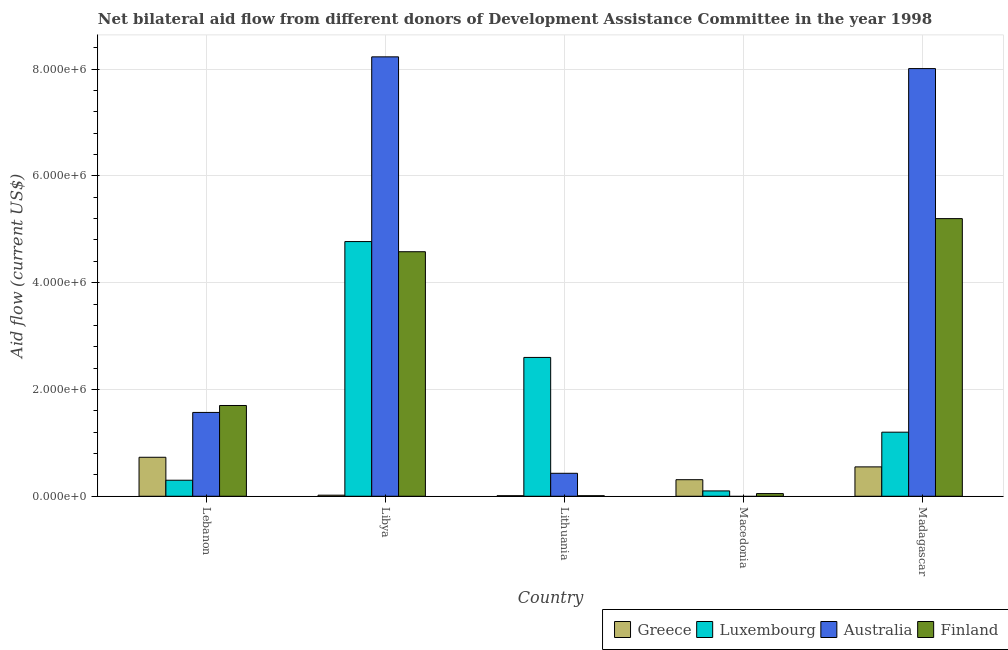How many different coloured bars are there?
Offer a very short reply. 4. How many groups of bars are there?
Your answer should be very brief. 5. How many bars are there on the 3rd tick from the left?
Your answer should be very brief. 4. What is the label of the 1st group of bars from the left?
Ensure brevity in your answer.  Lebanon. What is the amount of aid given by finland in Lithuania?
Ensure brevity in your answer.  10000. Across all countries, what is the maximum amount of aid given by luxembourg?
Your response must be concise. 4.77e+06. Across all countries, what is the minimum amount of aid given by luxembourg?
Offer a very short reply. 1.00e+05. In which country was the amount of aid given by luxembourg maximum?
Give a very brief answer. Libya. What is the total amount of aid given by luxembourg in the graph?
Make the answer very short. 8.97e+06. What is the difference between the amount of aid given by finland in Libya and that in Macedonia?
Make the answer very short. 4.53e+06. What is the difference between the amount of aid given by finland in Madagascar and the amount of aid given by luxembourg in Libya?
Ensure brevity in your answer.  4.30e+05. What is the average amount of aid given by luxembourg per country?
Keep it short and to the point. 1.79e+06. What is the difference between the amount of aid given by luxembourg and amount of aid given by greece in Macedonia?
Provide a short and direct response. -2.10e+05. What is the ratio of the amount of aid given by luxembourg in Libya to that in Madagascar?
Ensure brevity in your answer.  3.98. What is the difference between the highest and the second highest amount of aid given by australia?
Provide a succinct answer. 2.20e+05. What is the difference between the highest and the lowest amount of aid given by finland?
Keep it short and to the point. 5.19e+06. Is the sum of the amount of aid given by luxembourg in Lithuania and Macedonia greater than the maximum amount of aid given by australia across all countries?
Make the answer very short. No. Is it the case that in every country, the sum of the amount of aid given by greece and amount of aid given by luxembourg is greater than the amount of aid given by australia?
Your answer should be very brief. No. What is the difference between two consecutive major ticks on the Y-axis?
Your answer should be compact. 2.00e+06. Where does the legend appear in the graph?
Your response must be concise. Bottom right. How are the legend labels stacked?
Make the answer very short. Horizontal. What is the title of the graph?
Ensure brevity in your answer.  Net bilateral aid flow from different donors of Development Assistance Committee in the year 1998. What is the label or title of the X-axis?
Make the answer very short. Country. What is the Aid flow (current US$) in Greece in Lebanon?
Provide a short and direct response. 7.30e+05. What is the Aid flow (current US$) in Australia in Lebanon?
Provide a short and direct response. 1.57e+06. What is the Aid flow (current US$) of Finland in Lebanon?
Offer a terse response. 1.70e+06. What is the Aid flow (current US$) in Greece in Libya?
Provide a succinct answer. 2.00e+04. What is the Aid flow (current US$) of Luxembourg in Libya?
Offer a terse response. 4.77e+06. What is the Aid flow (current US$) in Australia in Libya?
Keep it short and to the point. 8.23e+06. What is the Aid flow (current US$) in Finland in Libya?
Ensure brevity in your answer.  4.58e+06. What is the Aid flow (current US$) of Greece in Lithuania?
Offer a terse response. 10000. What is the Aid flow (current US$) of Luxembourg in Lithuania?
Give a very brief answer. 2.60e+06. What is the Aid flow (current US$) of Finland in Lithuania?
Give a very brief answer. 10000. What is the Aid flow (current US$) of Greece in Macedonia?
Your response must be concise. 3.10e+05. What is the Aid flow (current US$) of Australia in Macedonia?
Your answer should be compact. 0. What is the Aid flow (current US$) in Finland in Macedonia?
Ensure brevity in your answer.  5.00e+04. What is the Aid flow (current US$) in Greece in Madagascar?
Ensure brevity in your answer.  5.50e+05. What is the Aid flow (current US$) of Luxembourg in Madagascar?
Your response must be concise. 1.20e+06. What is the Aid flow (current US$) in Australia in Madagascar?
Make the answer very short. 8.01e+06. What is the Aid flow (current US$) in Finland in Madagascar?
Make the answer very short. 5.20e+06. Across all countries, what is the maximum Aid flow (current US$) of Greece?
Your answer should be compact. 7.30e+05. Across all countries, what is the maximum Aid flow (current US$) of Luxembourg?
Offer a terse response. 4.77e+06. Across all countries, what is the maximum Aid flow (current US$) of Australia?
Your answer should be compact. 8.23e+06. Across all countries, what is the maximum Aid flow (current US$) of Finland?
Offer a very short reply. 5.20e+06. Across all countries, what is the minimum Aid flow (current US$) in Greece?
Provide a short and direct response. 10000. Across all countries, what is the minimum Aid flow (current US$) in Luxembourg?
Your answer should be very brief. 1.00e+05. Across all countries, what is the minimum Aid flow (current US$) of Australia?
Your answer should be compact. 0. Across all countries, what is the minimum Aid flow (current US$) in Finland?
Offer a very short reply. 10000. What is the total Aid flow (current US$) in Greece in the graph?
Give a very brief answer. 1.62e+06. What is the total Aid flow (current US$) in Luxembourg in the graph?
Offer a terse response. 8.97e+06. What is the total Aid flow (current US$) in Australia in the graph?
Your answer should be very brief. 1.82e+07. What is the total Aid flow (current US$) in Finland in the graph?
Offer a very short reply. 1.15e+07. What is the difference between the Aid flow (current US$) of Greece in Lebanon and that in Libya?
Your answer should be compact. 7.10e+05. What is the difference between the Aid flow (current US$) of Luxembourg in Lebanon and that in Libya?
Offer a terse response. -4.47e+06. What is the difference between the Aid flow (current US$) of Australia in Lebanon and that in Libya?
Your answer should be compact. -6.66e+06. What is the difference between the Aid flow (current US$) of Finland in Lebanon and that in Libya?
Your answer should be compact. -2.88e+06. What is the difference between the Aid flow (current US$) in Greece in Lebanon and that in Lithuania?
Offer a terse response. 7.20e+05. What is the difference between the Aid flow (current US$) of Luxembourg in Lebanon and that in Lithuania?
Make the answer very short. -2.30e+06. What is the difference between the Aid flow (current US$) of Australia in Lebanon and that in Lithuania?
Make the answer very short. 1.14e+06. What is the difference between the Aid flow (current US$) in Finland in Lebanon and that in Lithuania?
Your response must be concise. 1.69e+06. What is the difference between the Aid flow (current US$) in Greece in Lebanon and that in Macedonia?
Make the answer very short. 4.20e+05. What is the difference between the Aid flow (current US$) of Luxembourg in Lebanon and that in Macedonia?
Make the answer very short. 2.00e+05. What is the difference between the Aid flow (current US$) of Finland in Lebanon and that in Macedonia?
Ensure brevity in your answer.  1.65e+06. What is the difference between the Aid flow (current US$) of Luxembourg in Lebanon and that in Madagascar?
Your response must be concise. -9.00e+05. What is the difference between the Aid flow (current US$) of Australia in Lebanon and that in Madagascar?
Your response must be concise. -6.44e+06. What is the difference between the Aid flow (current US$) in Finland in Lebanon and that in Madagascar?
Offer a terse response. -3.50e+06. What is the difference between the Aid flow (current US$) in Greece in Libya and that in Lithuania?
Your answer should be compact. 10000. What is the difference between the Aid flow (current US$) of Luxembourg in Libya and that in Lithuania?
Your answer should be very brief. 2.17e+06. What is the difference between the Aid flow (current US$) in Australia in Libya and that in Lithuania?
Your answer should be compact. 7.80e+06. What is the difference between the Aid flow (current US$) of Finland in Libya and that in Lithuania?
Your response must be concise. 4.57e+06. What is the difference between the Aid flow (current US$) in Greece in Libya and that in Macedonia?
Your answer should be very brief. -2.90e+05. What is the difference between the Aid flow (current US$) in Luxembourg in Libya and that in Macedonia?
Provide a succinct answer. 4.67e+06. What is the difference between the Aid flow (current US$) of Finland in Libya and that in Macedonia?
Your answer should be very brief. 4.53e+06. What is the difference between the Aid flow (current US$) in Greece in Libya and that in Madagascar?
Ensure brevity in your answer.  -5.30e+05. What is the difference between the Aid flow (current US$) of Luxembourg in Libya and that in Madagascar?
Your response must be concise. 3.57e+06. What is the difference between the Aid flow (current US$) in Australia in Libya and that in Madagascar?
Your answer should be compact. 2.20e+05. What is the difference between the Aid flow (current US$) of Finland in Libya and that in Madagascar?
Offer a terse response. -6.20e+05. What is the difference between the Aid flow (current US$) in Greece in Lithuania and that in Macedonia?
Make the answer very short. -3.00e+05. What is the difference between the Aid flow (current US$) in Luxembourg in Lithuania and that in Macedonia?
Ensure brevity in your answer.  2.50e+06. What is the difference between the Aid flow (current US$) in Finland in Lithuania and that in Macedonia?
Your answer should be very brief. -4.00e+04. What is the difference between the Aid flow (current US$) of Greece in Lithuania and that in Madagascar?
Provide a succinct answer. -5.40e+05. What is the difference between the Aid flow (current US$) in Luxembourg in Lithuania and that in Madagascar?
Offer a terse response. 1.40e+06. What is the difference between the Aid flow (current US$) in Australia in Lithuania and that in Madagascar?
Offer a very short reply. -7.58e+06. What is the difference between the Aid flow (current US$) of Finland in Lithuania and that in Madagascar?
Make the answer very short. -5.19e+06. What is the difference between the Aid flow (current US$) of Luxembourg in Macedonia and that in Madagascar?
Ensure brevity in your answer.  -1.10e+06. What is the difference between the Aid flow (current US$) of Finland in Macedonia and that in Madagascar?
Provide a short and direct response. -5.15e+06. What is the difference between the Aid flow (current US$) of Greece in Lebanon and the Aid flow (current US$) of Luxembourg in Libya?
Your answer should be compact. -4.04e+06. What is the difference between the Aid flow (current US$) of Greece in Lebanon and the Aid flow (current US$) of Australia in Libya?
Your answer should be very brief. -7.50e+06. What is the difference between the Aid flow (current US$) of Greece in Lebanon and the Aid flow (current US$) of Finland in Libya?
Offer a very short reply. -3.85e+06. What is the difference between the Aid flow (current US$) of Luxembourg in Lebanon and the Aid flow (current US$) of Australia in Libya?
Your answer should be very brief. -7.93e+06. What is the difference between the Aid flow (current US$) in Luxembourg in Lebanon and the Aid flow (current US$) in Finland in Libya?
Offer a very short reply. -4.28e+06. What is the difference between the Aid flow (current US$) of Australia in Lebanon and the Aid flow (current US$) of Finland in Libya?
Provide a succinct answer. -3.01e+06. What is the difference between the Aid flow (current US$) in Greece in Lebanon and the Aid flow (current US$) in Luxembourg in Lithuania?
Provide a short and direct response. -1.87e+06. What is the difference between the Aid flow (current US$) of Greece in Lebanon and the Aid flow (current US$) of Finland in Lithuania?
Provide a short and direct response. 7.20e+05. What is the difference between the Aid flow (current US$) in Luxembourg in Lebanon and the Aid flow (current US$) in Australia in Lithuania?
Provide a succinct answer. -1.30e+05. What is the difference between the Aid flow (current US$) of Australia in Lebanon and the Aid flow (current US$) of Finland in Lithuania?
Ensure brevity in your answer.  1.56e+06. What is the difference between the Aid flow (current US$) in Greece in Lebanon and the Aid flow (current US$) in Luxembourg in Macedonia?
Your answer should be very brief. 6.30e+05. What is the difference between the Aid flow (current US$) of Greece in Lebanon and the Aid flow (current US$) of Finland in Macedonia?
Provide a succinct answer. 6.80e+05. What is the difference between the Aid flow (current US$) in Luxembourg in Lebanon and the Aid flow (current US$) in Finland in Macedonia?
Your answer should be very brief. 2.50e+05. What is the difference between the Aid flow (current US$) in Australia in Lebanon and the Aid flow (current US$) in Finland in Macedonia?
Give a very brief answer. 1.52e+06. What is the difference between the Aid flow (current US$) of Greece in Lebanon and the Aid flow (current US$) of Luxembourg in Madagascar?
Your answer should be compact. -4.70e+05. What is the difference between the Aid flow (current US$) of Greece in Lebanon and the Aid flow (current US$) of Australia in Madagascar?
Your answer should be compact. -7.28e+06. What is the difference between the Aid flow (current US$) of Greece in Lebanon and the Aid flow (current US$) of Finland in Madagascar?
Give a very brief answer. -4.47e+06. What is the difference between the Aid flow (current US$) of Luxembourg in Lebanon and the Aid flow (current US$) of Australia in Madagascar?
Provide a succinct answer. -7.71e+06. What is the difference between the Aid flow (current US$) of Luxembourg in Lebanon and the Aid flow (current US$) of Finland in Madagascar?
Keep it short and to the point. -4.90e+06. What is the difference between the Aid flow (current US$) in Australia in Lebanon and the Aid flow (current US$) in Finland in Madagascar?
Make the answer very short. -3.63e+06. What is the difference between the Aid flow (current US$) in Greece in Libya and the Aid flow (current US$) in Luxembourg in Lithuania?
Ensure brevity in your answer.  -2.58e+06. What is the difference between the Aid flow (current US$) of Greece in Libya and the Aid flow (current US$) of Australia in Lithuania?
Provide a short and direct response. -4.10e+05. What is the difference between the Aid flow (current US$) in Greece in Libya and the Aid flow (current US$) in Finland in Lithuania?
Your answer should be very brief. 10000. What is the difference between the Aid flow (current US$) of Luxembourg in Libya and the Aid flow (current US$) of Australia in Lithuania?
Keep it short and to the point. 4.34e+06. What is the difference between the Aid flow (current US$) in Luxembourg in Libya and the Aid flow (current US$) in Finland in Lithuania?
Your response must be concise. 4.76e+06. What is the difference between the Aid flow (current US$) of Australia in Libya and the Aid flow (current US$) of Finland in Lithuania?
Give a very brief answer. 8.22e+06. What is the difference between the Aid flow (current US$) of Greece in Libya and the Aid flow (current US$) of Finland in Macedonia?
Offer a terse response. -3.00e+04. What is the difference between the Aid flow (current US$) in Luxembourg in Libya and the Aid flow (current US$) in Finland in Macedonia?
Offer a terse response. 4.72e+06. What is the difference between the Aid flow (current US$) of Australia in Libya and the Aid flow (current US$) of Finland in Macedonia?
Provide a succinct answer. 8.18e+06. What is the difference between the Aid flow (current US$) in Greece in Libya and the Aid flow (current US$) in Luxembourg in Madagascar?
Your response must be concise. -1.18e+06. What is the difference between the Aid flow (current US$) of Greece in Libya and the Aid flow (current US$) of Australia in Madagascar?
Offer a very short reply. -7.99e+06. What is the difference between the Aid flow (current US$) in Greece in Libya and the Aid flow (current US$) in Finland in Madagascar?
Offer a terse response. -5.18e+06. What is the difference between the Aid flow (current US$) of Luxembourg in Libya and the Aid flow (current US$) of Australia in Madagascar?
Your answer should be compact. -3.24e+06. What is the difference between the Aid flow (current US$) of Luxembourg in Libya and the Aid flow (current US$) of Finland in Madagascar?
Your answer should be compact. -4.30e+05. What is the difference between the Aid flow (current US$) in Australia in Libya and the Aid flow (current US$) in Finland in Madagascar?
Keep it short and to the point. 3.03e+06. What is the difference between the Aid flow (current US$) in Luxembourg in Lithuania and the Aid flow (current US$) in Finland in Macedonia?
Your answer should be compact. 2.55e+06. What is the difference between the Aid flow (current US$) of Greece in Lithuania and the Aid flow (current US$) of Luxembourg in Madagascar?
Your response must be concise. -1.19e+06. What is the difference between the Aid flow (current US$) of Greece in Lithuania and the Aid flow (current US$) of Australia in Madagascar?
Keep it short and to the point. -8.00e+06. What is the difference between the Aid flow (current US$) of Greece in Lithuania and the Aid flow (current US$) of Finland in Madagascar?
Ensure brevity in your answer.  -5.19e+06. What is the difference between the Aid flow (current US$) of Luxembourg in Lithuania and the Aid flow (current US$) of Australia in Madagascar?
Keep it short and to the point. -5.41e+06. What is the difference between the Aid flow (current US$) in Luxembourg in Lithuania and the Aid flow (current US$) in Finland in Madagascar?
Keep it short and to the point. -2.60e+06. What is the difference between the Aid flow (current US$) in Australia in Lithuania and the Aid flow (current US$) in Finland in Madagascar?
Your answer should be compact. -4.77e+06. What is the difference between the Aid flow (current US$) of Greece in Macedonia and the Aid flow (current US$) of Luxembourg in Madagascar?
Offer a very short reply. -8.90e+05. What is the difference between the Aid flow (current US$) in Greece in Macedonia and the Aid flow (current US$) in Australia in Madagascar?
Offer a terse response. -7.70e+06. What is the difference between the Aid flow (current US$) in Greece in Macedonia and the Aid flow (current US$) in Finland in Madagascar?
Provide a short and direct response. -4.89e+06. What is the difference between the Aid flow (current US$) of Luxembourg in Macedonia and the Aid flow (current US$) of Australia in Madagascar?
Keep it short and to the point. -7.91e+06. What is the difference between the Aid flow (current US$) of Luxembourg in Macedonia and the Aid flow (current US$) of Finland in Madagascar?
Your answer should be very brief. -5.10e+06. What is the average Aid flow (current US$) of Greece per country?
Offer a terse response. 3.24e+05. What is the average Aid flow (current US$) in Luxembourg per country?
Offer a very short reply. 1.79e+06. What is the average Aid flow (current US$) of Australia per country?
Offer a very short reply. 3.65e+06. What is the average Aid flow (current US$) in Finland per country?
Your answer should be very brief. 2.31e+06. What is the difference between the Aid flow (current US$) of Greece and Aid flow (current US$) of Luxembourg in Lebanon?
Provide a short and direct response. 4.30e+05. What is the difference between the Aid flow (current US$) of Greece and Aid flow (current US$) of Australia in Lebanon?
Offer a very short reply. -8.40e+05. What is the difference between the Aid flow (current US$) of Greece and Aid flow (current US$) of Finland in Lebanon?
Ensure brevity in your answer.  -9.70e+05. What is the difference between the Aid flow (current US$) of Luxembourg and Aid flow (current US$) of Australia in Lebanon?
Your answer should be very brief. -1.27e+06. What is the difference between the Aid flow (current US$) of Luxembourg and Aid flow (current US$) of Finland in Lebanon?
Your answer should be compact. -1.40e+06. What is the difference between the Aid flow (current US$) of Greece and Aid flow (current US$) of Luxembourg in Libya?
Your answer should be very brief. -4.75e+06. What is the difference between the Aid flow (current US$) of Greece and Aid flow (current US$) of Australia in Libya?
Your answer should be very brief. -8.21e+06. What is the difference between the Aid flow (current US$) of Greece and Aid flow (current US$) of Finland in Libya?
Your answer should be compact. -4.56e+06. What is the difference between the Aid flow (current US$) in Luxembourg and Aid flow (current US$) in Australia in Libya?
Your answer should be compact. -3.46e+06. What is the difference between the Aid flow (current US$) of Australia and Aid flow (current US$) of Finland in Libya?
Provide a short and direct response. 3.65e+06. What is the difference between the Aid flow (current US$) in Greece and Aid flow (current US$) in Luxembourg in Lithuania?
Offer a terse response. -2.59e+06. What is the difference between the Aid flow (current US$) in Greece and Aid flow (current US$) in Australia in Lithuania?
Your response must be concise. -4.20e+05. What is the difference between the Aid flow (current US$) in Greece and Aid flow (current US$) in Finland in Lithuania?
Your answer should be compact. 0. What is the difference between the Aid flow (current US$) of Luxembourg and Aid flow (current US$) of Australia in Lithuania?
Give a very brief answer. 2.17e+06. What is the difference between the Aid flow (current US$) of Luxembourg and Aid flow (current US$) of Finland in Lithuania?
Make the answer very short. 2.59e+06. What is the difference between the Aid flow (current US$) of Australia and Aid flow (current US$) of Finland in Lithuania?
Provide a short and direct response. 4.20e+05. What is the difference between the Aid flow (current US$) of Greece and Aid flow (current US$) of Finland in Macedonia?
Your response must be concise. 2.60e+05. What is the difference between the Aid flow (current US$) of Greece and Aid flow (current US$) of Luxembourg in Madagascar?
Keep it short and to the point. -6.50e+05. What is the difference between the Aid flow (current US$) of Greece and Aid flow (current US$) of Australia in Madagascar?
Ensure brevity in your answer.  -7.46e+06. What is the difference between the Aid flow (current US$) in Greece and Aid flow (current US$) in Finland in Madagascar?
Ensure brevity in your answer.  -4.65e+06. What is the difference between the Aid flow (current US$) in Luxembourg and Aid flow (current US$) in Australia in Madagascar?
Your response must be concise. -6.81e+06. What is the difference between the Aid flow (current US$) in Luxembourg and Aid flow (current US$) in Finland in Madagascar?
Give a very brief answer. -4.00e+06. What is the difference between the Aid flow (current US$) of Australia and Aid flow (current US$) of Finland in Madagascar?
Keep it short and to the point. 2.81e+06. What is the ratio of the Aid flow (current US$) in Greece in Lebanon to that in Libya?
Your response must be concise. 36.5. What is the ratio of the Aid flow (current US$) in Luxembourg in Lebanon to that in Libya?
Make the answer very short. 0.06. What is the ratio of the Aid flow (current US$) in Australia in Lebanon to that in Libya?
Ensure brevity in your answer.  0.19. What is the ratio of the Aid flow (current US$) in Finland in Lebanon to that in Libya?
Offer a very short reply. 0.37. What is the ratio of the Aid flow (current US$) of Greece in Lebanon to that in Lithuania?
Offer a terse response. 73. What is the ratio of the Aid flow (current US$) in Luxembourg in Lebanon to that in Lithuania?
Offer a very short reply. 0.12. What is the ratio of the Aid flow (current US$) of Australia in Lebanon to that in Lithuania?
Provide a short and direct response. 3.65. What is the ratio of the Aid flow (current US$) in Finland in Lebanon to that in Lithuania?
Keep it short and to the point. 170. What is the ratio of the Aid flow (current US$) in Greece in Lebanon to that in Macedonia?
Ensure brevity in your answer.  2.35. What is the ratio of the Aid flow (current US$) in Finland in Lebanon to that in Macedonia?
Your answer should be compact. 34. What is the ratio of the Aid flow (current US$) of Greece in Lebanon to that in Madagascar?
Provide a short and direct response. 1.33. What is the ratio of the Aid flow (current US$) in Luxembourg in Lebanon to that in Madagascar?
Provide a short and direct response. 0.25. What is the ratio of the Aid flow (current US$) in Australia in Lebanon to that in Madagascar?
Offer a terse response. 0.2. What is the ratio of the Aid flow (current US$) in Finland in Lebanon to that in Madagascar?
Your answer should be very brief. 0.33. What is the ratio of the Aid flow (current US$) of Luxembourg in Libya to that in Lithuania?
Ensure brevity in your answer.  1.83. What is the ratio of the Aid flow (current US$) of Australia in Libya to that in Lithuania?
Offer a terse response. 19.14. What is the ratio of the Aid flow (current US$) in Finland in Libya to that in Lithuania?
Ensure brevity in your answer.  458. What is the ratio of the Aid flow (current US$) of Greece in Libya to that in Macedonia?
Give a very brief answer. 0.06. What is the ratio of the Aid flow (current US$) of Luxembourg in Libya to that in Macedonia?
Offer a terse response. 47.7. What is the ratio of the Aid flow (current US$) of Finland in Libya to that in Macedonia?
Provide a succinct answer. 91.6. What is the ratio of the Aid flow (current US$) of Greece in Libya to that in Madagascar?
Make the answer very short. 0.04. What is the ratio of the Aid flow (current US$) in Luxembourg in Libya to that in Madagascar?
Ensure brevity in your answer.  3.98. What is the ratio of the Aid flow (current US$) in Australia in Libya to that in Madagascar?
Make the answer very short. 1.03. What is the ratio of the Aid flow (current US$) of Finland in Libya to that in Madagascar?
Your answer should be compact. 0.88. What is the ratio of the Aid flow (current US$) of Greece in Lithuania to that in Macedonia?
Offer a very short reply. 0.03. What is the ratio of the Aid flow (current US$) of Finland in Lithuania to that in Macedonia?
Provide a succinct answer. 0.2. What is the ratio of the Aid flow (current US$) in Greece in Lithuania to that in Madagascar?
Give a very brief answer. 0.02. What is the ratio of the Aid flow (current US$) in Luxembourg in Lithuania to that in Madagascar?
Make the answer very short. 2.17. What is the ratio of the Aid flow (current US$) in Australia in Lithuania to that in Madagascar?
Give a very brief answer. 0.05. What is the ratio of the Aid flow (current US$) in Finland in Lithuania to that in Madagascar?
Your response must be concise. 0. What is the ratio of the Aid flow (current US$) in Greece in Macedonia to that in Madagascar?
Keep it short and to the point. 0.56. What is the ratio of the Aid flow (current US$) of Luxembourg in Macedonia to that in Madagascar?
Your answer should be compact. 0.08. What is the ratio of the Aid flow (current US$) of Finland in Macedonia to that in Madagascar?
Keep it short and to the point. 0.01. What is the difference between the highest and the second highest Aid flow (current US$) in Luxembourg?
Offer a very short reply. 2.17e+06. What is the difference between the highest and the second highest Aid flow (current US$) in Australia?
Your answer should be very brief. 2.20e+05. What is the difference between the highest and the second highest Aid flow (current US$) of Finland?
Keep it short and to the point. 6.20e+05. What is the difference between the highest and the lowest Aid flow (current US$) in Greece?
Give a very brief answer. 7.20e+05. What is the difference between the highest and the lowest Aid flow (current US$) in Luxembourg?
Give a very brief answer. 4.67e+06. What is the difference between the highest and the lowest Aid flow (current US$) of Australia?
Provide a succinct answer. 8.23e+06. What is the difference between the highest and the lowest Aid flow (current US$) of Finland?
Offer a very short reply. 5.19e+06. 